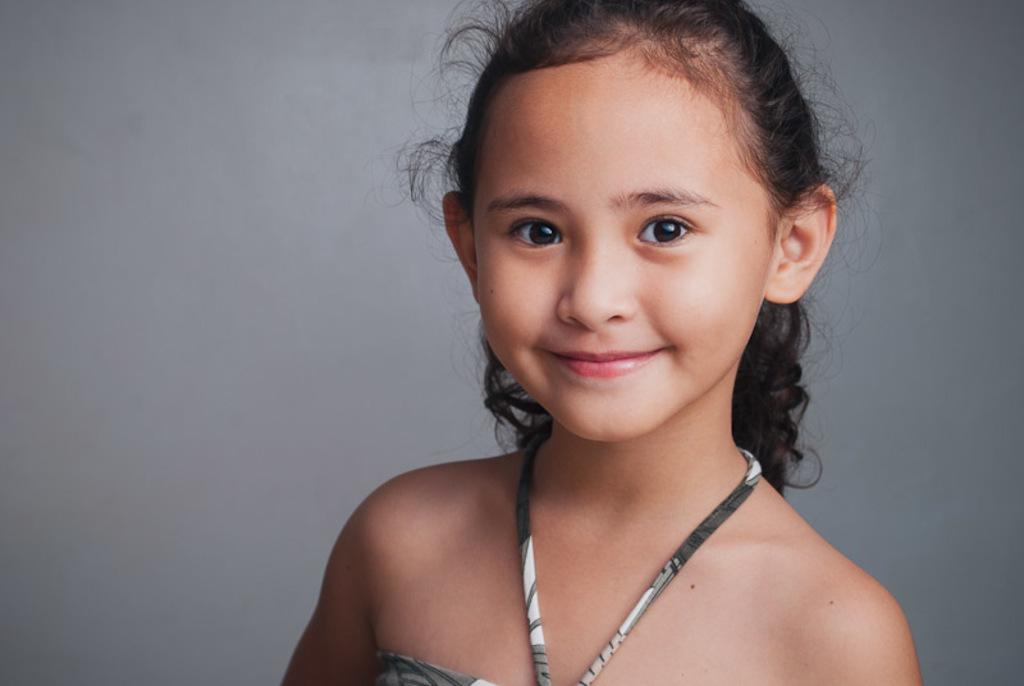Who is present in the image? There is a girl in the image. What expression does the girl have? The girl is smiling. What type of sand can be seen in the image? There is no sand present in the image. What time of day is it in the image, as indicated by the girl's watch? There is no watch visible on the girl in the image. 